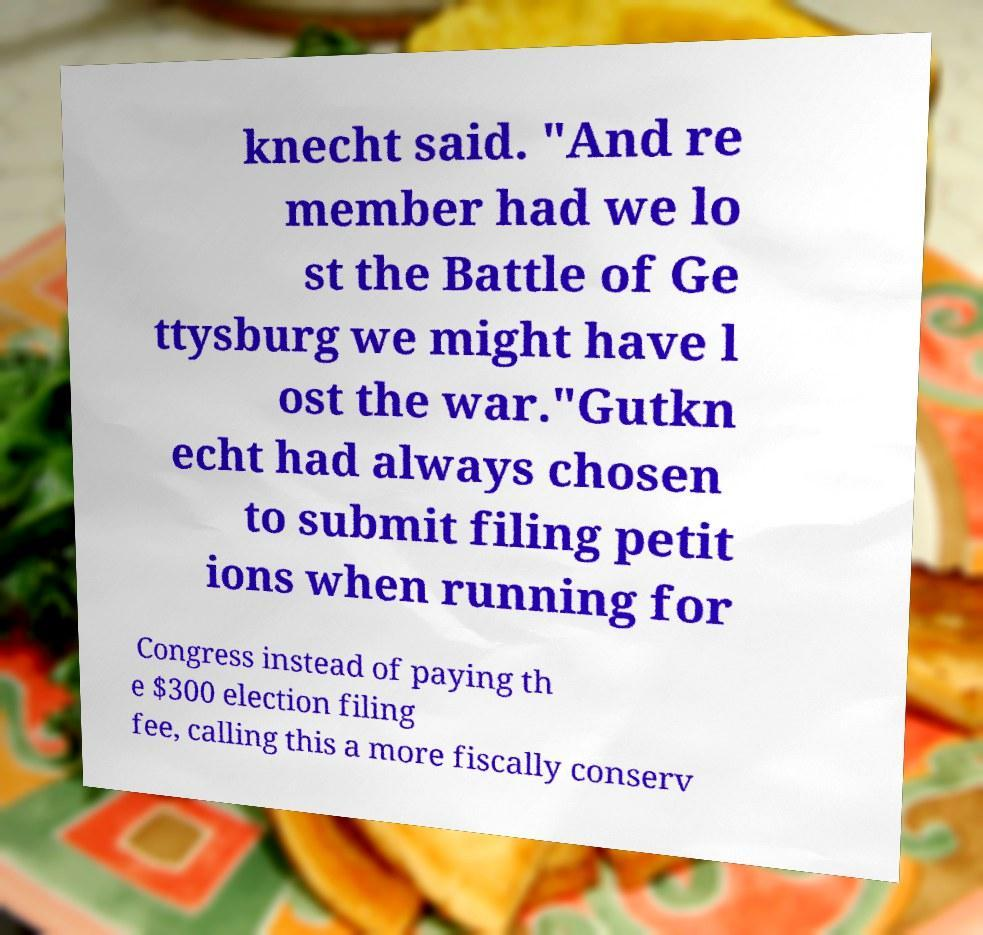Could you extract and type out the text from this image? knecht said. "And re member had we lo st the Battle of Ge ttysburg we might have l ost the war."Gutkn echt had always chosen to submit filing petit ions when running for Congress instead of paying th e $300 election filing fee, calling this a more fiscally conserv 